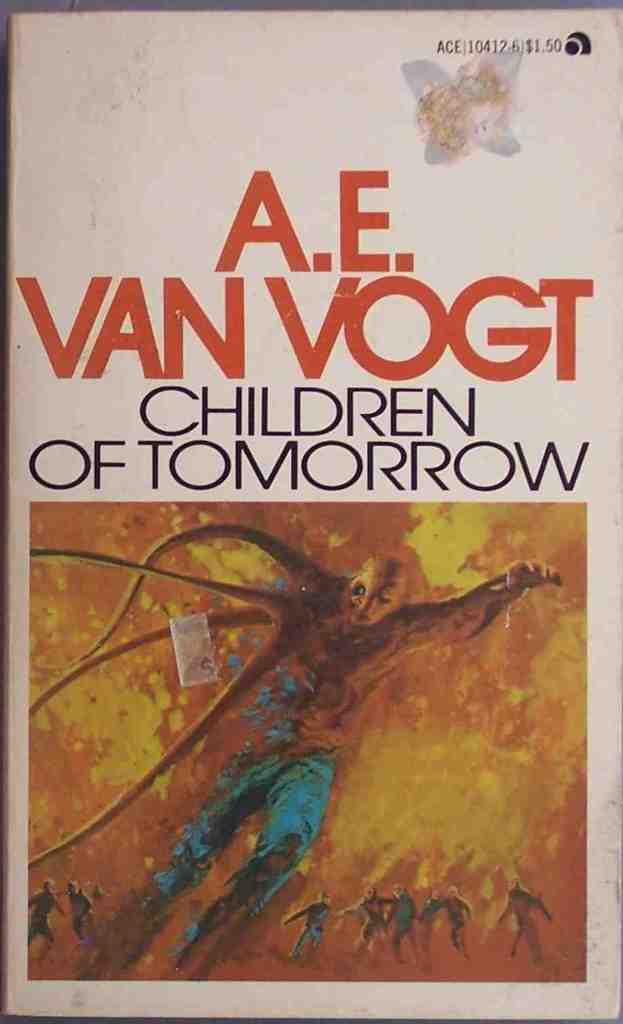<image>
Give a short and clear explanation of the subsequent image. a fire painting of a man on a book called Children of Tomorrow 